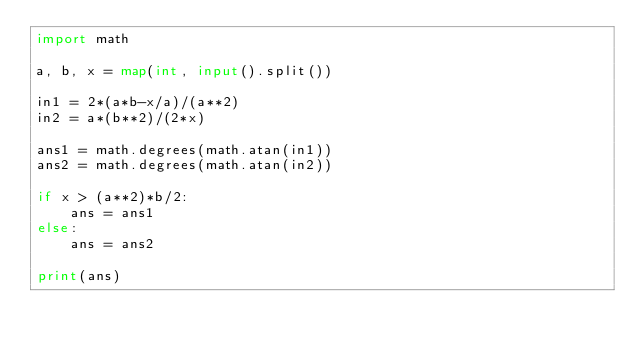<code> <loc_0><loc_0><loc_500><loc_500><_Python_>import math

a, b, x = map(int, input().split())

in1 = 2*(a*b-x/a)/(a**2)
in2 = a*(b**2)/(2*x)

ans1 = math.degrees(math.atan(in1))
ans2 = math.degrees(math.atan(in2))

if x > (a**2)*b/2:
    ans = ans1
else:
    ans = ans2

print(ans)</code> 